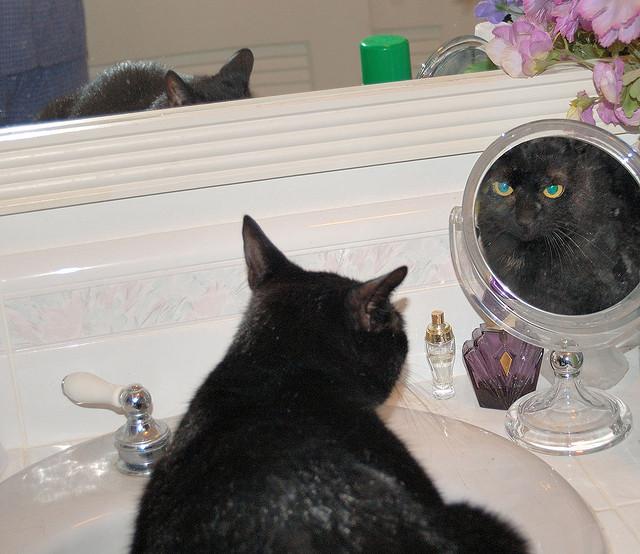What color is the cat's eyes?
Keep it brief. Yellow. Is the cat sitting in the sink?
Concise answer only. Yes. What is the cat looking at?
Concise answer only. Mirror. 